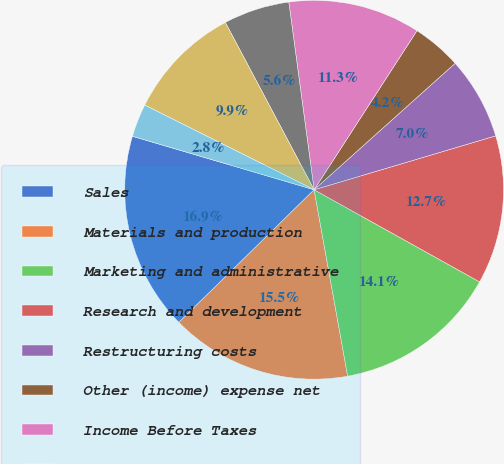Convert chart. <chart><loc_0><loc_0><loc_500><loc_500><pie_chart><fcel>Sales<fcel>Materials and production<fcel>Marketing and administrative<fcel>Research and development<fcel>Restructuring costs<fcel>Other (income) expense net<fcel>Income Before Taxes<fcel>Taxes on Income<fcel>Net Income<fcel>Less Net Income Attributable<nl><fcel>16.9%<fcel>15.49%<fcel>14.08%<fcel>12.68%<fcel>7.04%<fcel>4.23%<fcel>11.27%<fcel>5.63%<fcel>9.86%<fcel>2.82%<nl></chart> 